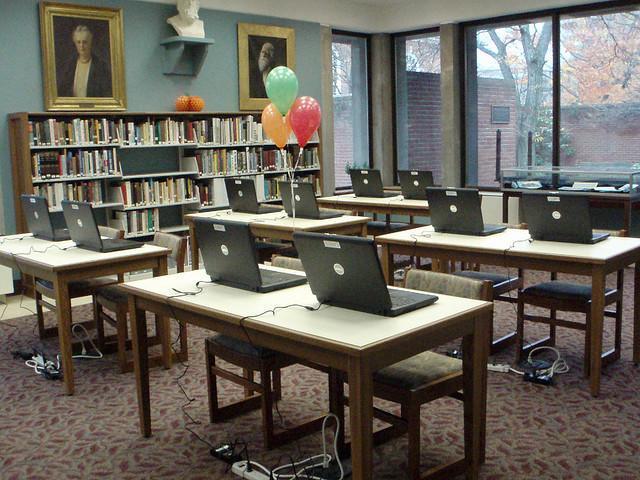How many people can sit at the same table?
Give a very brief answer. 2. How many laptops are there?
Give a very brief answer. 10. How many windows are there?
Give a very brief answer. 4. How many chairs are in the picture?
Give a very brief answer. 6. How many dining tables are there?
Give a very brief answer. 2. How many elephants are in the picture?
Give a very brief answer. 0. 